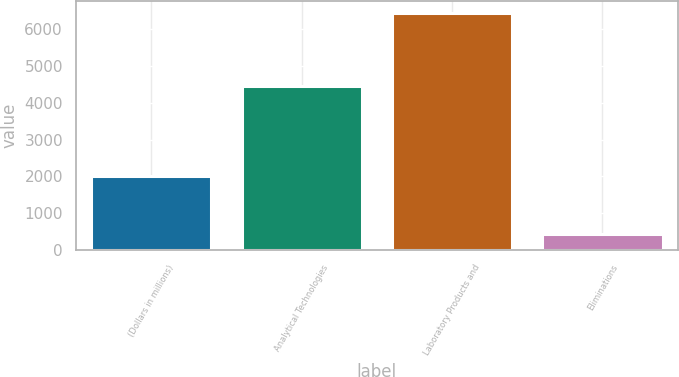Convert chart. <chart><loc_0><loc_0><loc_500><loc_500><bar_chart><fcel>(Dollars in millions)<fcel>Analytical Technologies<fcel>Laboratory Products and<fcel>Eliminations<nl><fcel>2008<fcel>4471.2<fcel>6453.3<fcel>426.5<nl></chart> 